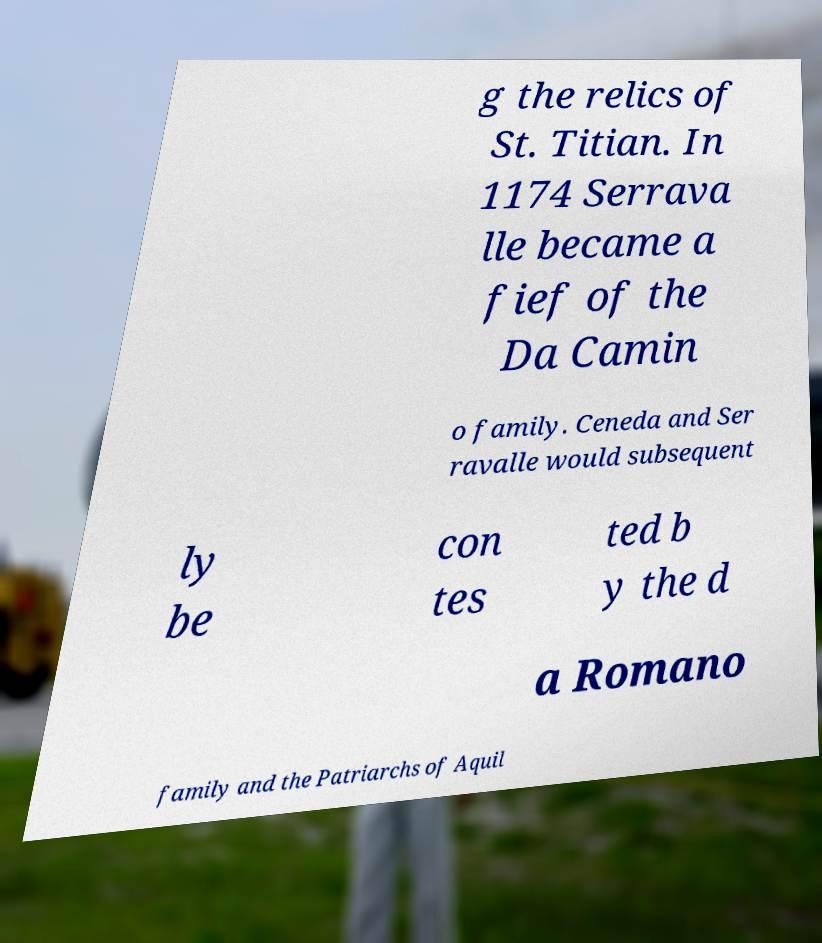There's text embedded in this image that I need extracted. Can you transcribe it verbatim? g the relics of St. Titian. In 1174 Serrava lle became a fief of the Da Camin o family. Ceneda and Ser ravalle would subsequent ly be con tes ted b y the d a Romano family and the Patriarchs of Aquil 